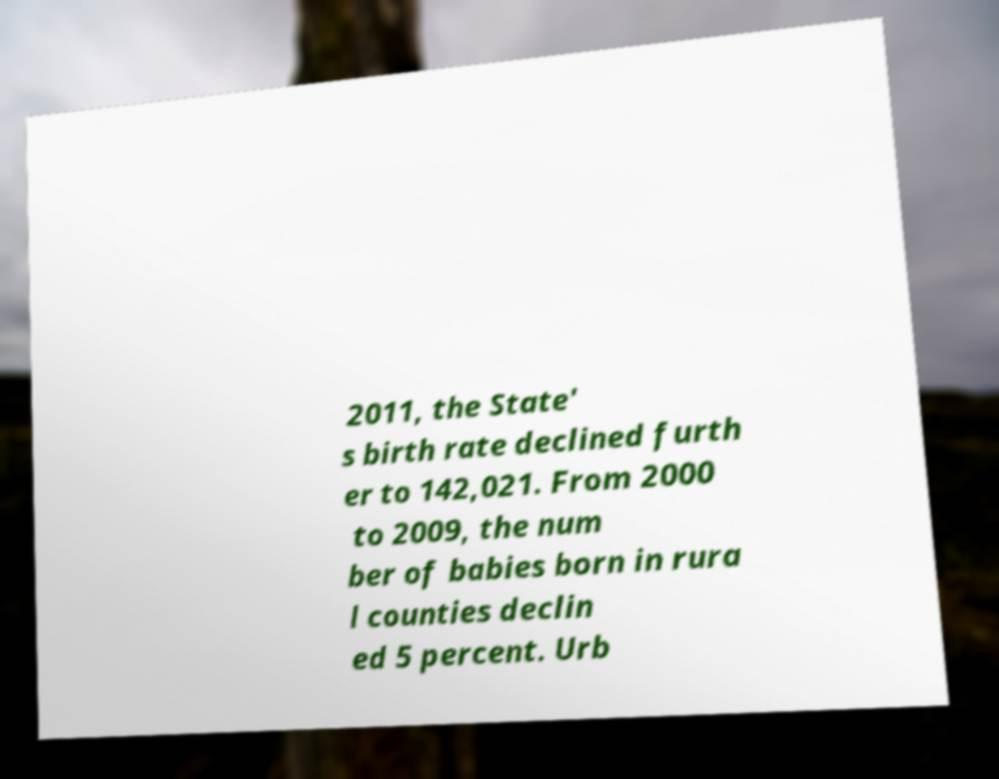Please read and relay the text visible in this image. What does it say? 2011, the State' s birth rate declined furth er to 142,021. From 2000 to 2009, the num ber of babies born in rura l counties declin ed 5 percent. Urb 